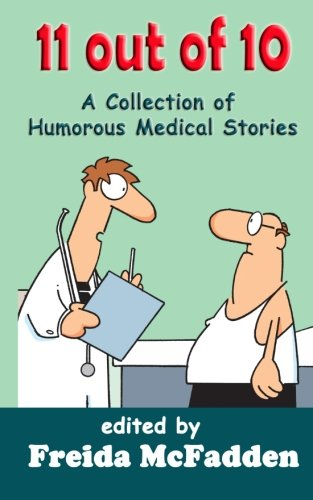Who is the author of this book?
Answer the question using a single word or phrase. Freida McFadden What is the title of this book? 11 out of 10: A Collection of Humorous Medical Short Stories What is the genre of this book? Mystery, Thriller & Suspense Is this a pharmaceutical book? No 